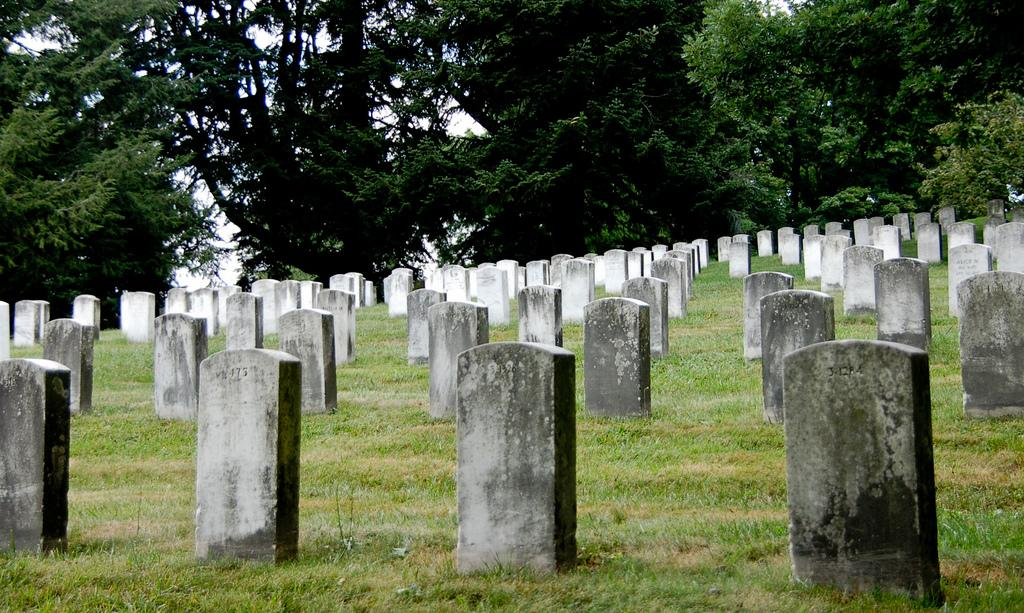What is the setting of the image? The image is taken in a graveyard. What can be seen among the graves in the image? There are many tombstones in the image. What type of vegetation is visible in the background of the image? There are trees in the background of the image. What is the ground surface like in the image? The ground with grass is visible at the bottom of the image. Where is the nest of the bird located in the image? There is no nest or bird present in the image; it is taken in a graveyard with tombstones and trees in the background. 